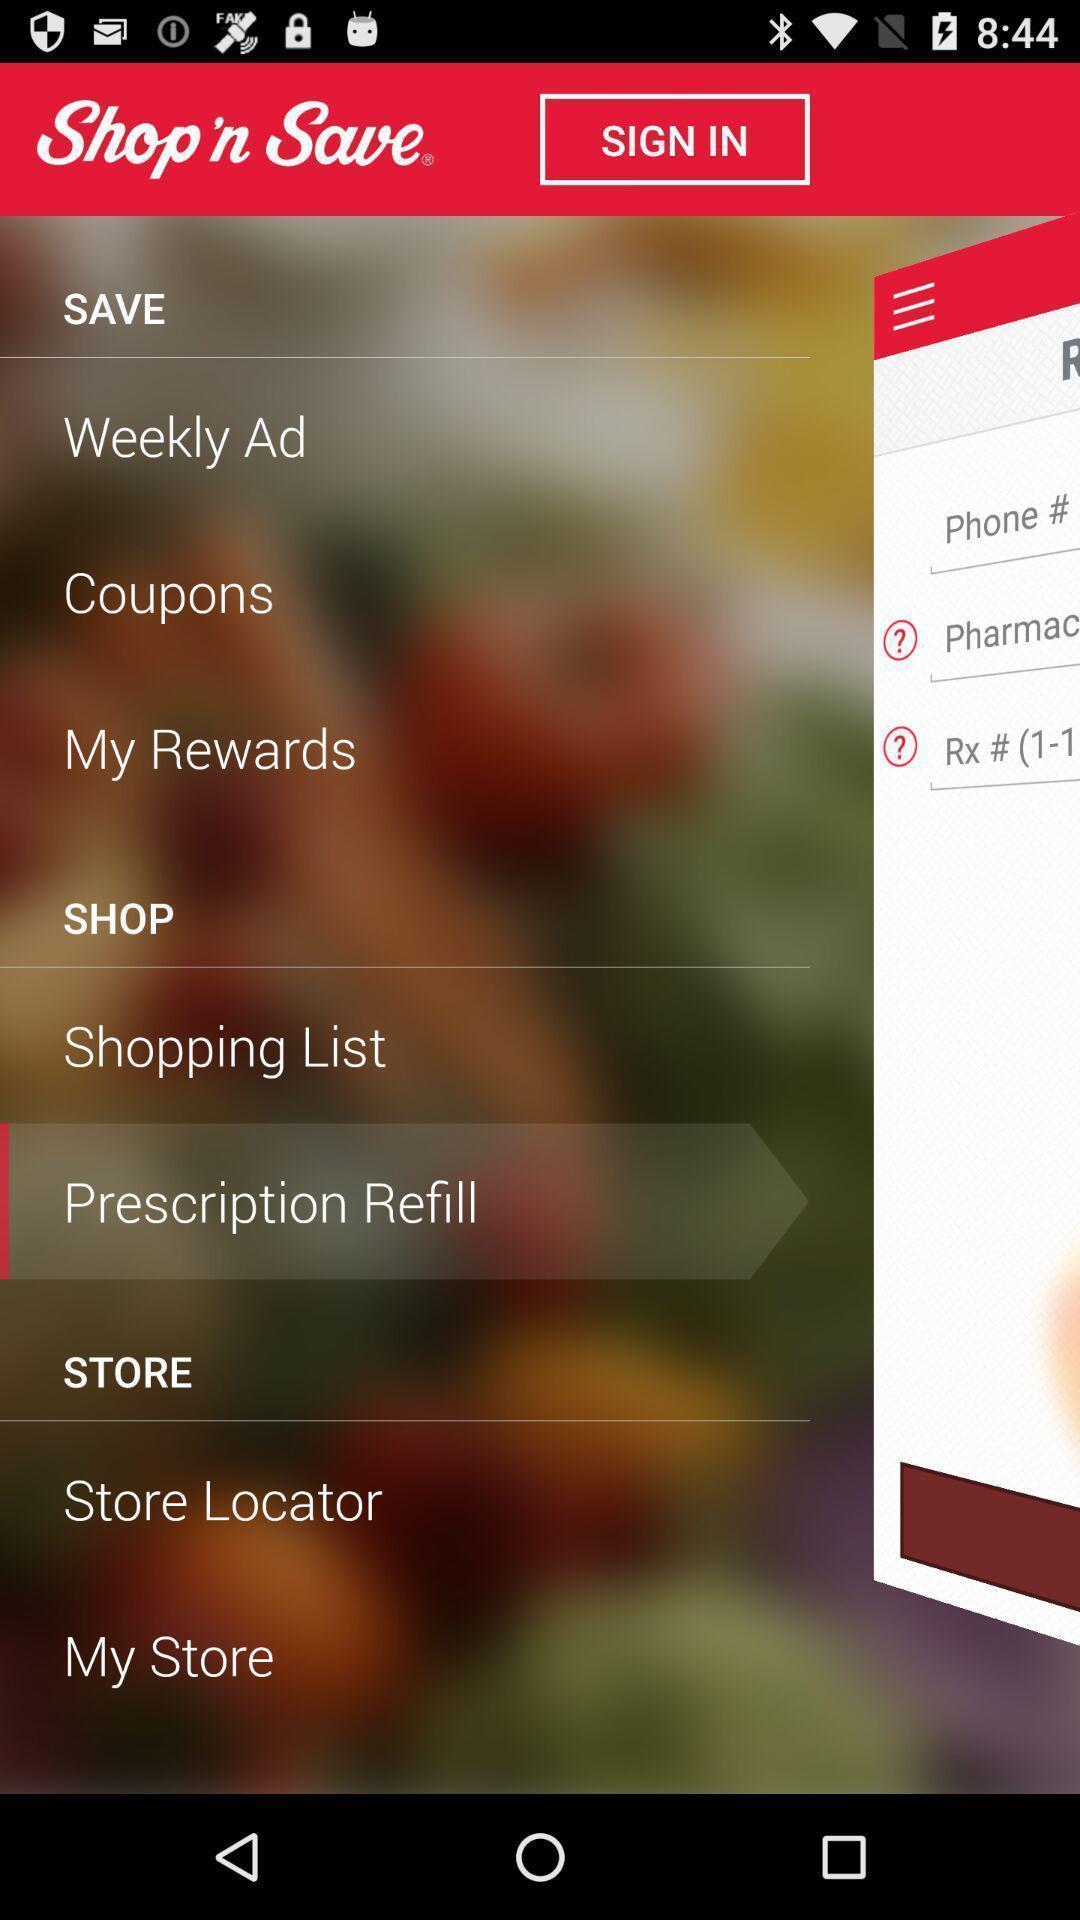Tell me what you see in this picture. Sign in page with options for a shopping application. 